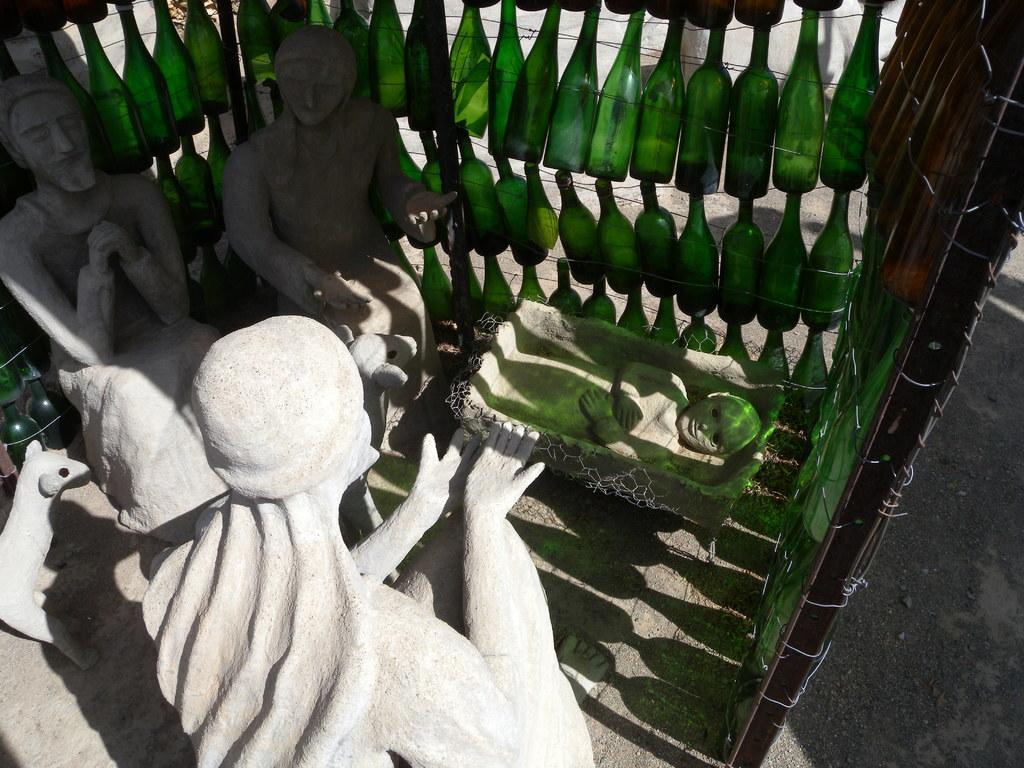Please provide a concise description of this image. In this picture we can see sculptures in the front, there are some bottles in the middle. 